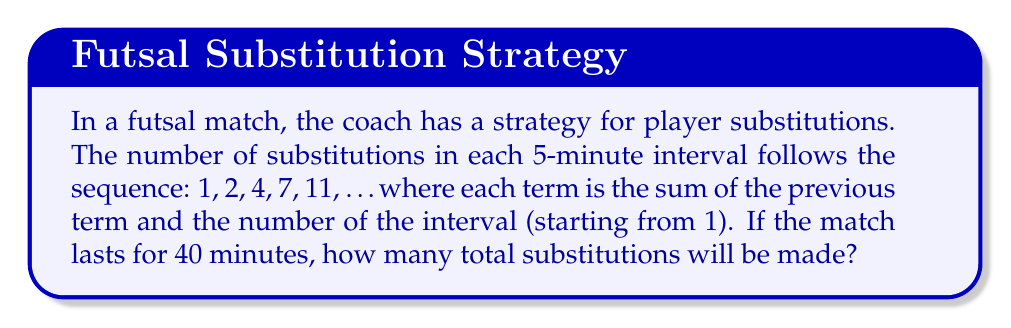Help me with this question. Let's break this down step-by-step:

1) First, we need to identify the sequence pattern:
   $a_1 = 1$
   $a_2 = 2 = 1 + 1$
   $a_3 = 4 = 2 + 2$
   $a_4 = 7 = 4 + 3$
   $a_5 = 11 = 7 + 4$

   The general term is: $a_n = a_{n-1} + n$

2) We need to find the sum of this sequence for 8 terms (since 40 minutes divided by 5-minute intervals gives us 8 intervals).

3) Let's calculate each term:
   $a_1 = 1$
   $a_2 = 1 + 2 = 3$
   $a_3 = 3 + 3 = 6$
   $a_4 = 6 + 4 = 10$
   $a_5 = 10 + 5 = 15$
   $a_6 = 15 + 6 = 21$
   $a_7 = 21 + 7 = 28$
   $a_8 = 28 + 8 = 36$

4) Now, we need to sum all these terms:

   $S = 1 + 3 + 6 + 10 + 15 + 21 + 28 + 36$

5) We can calculate this sum:

   $S = 120$

Therefore, the total number of substitutions made during the 40-minute match is 120.
Answer: 120 